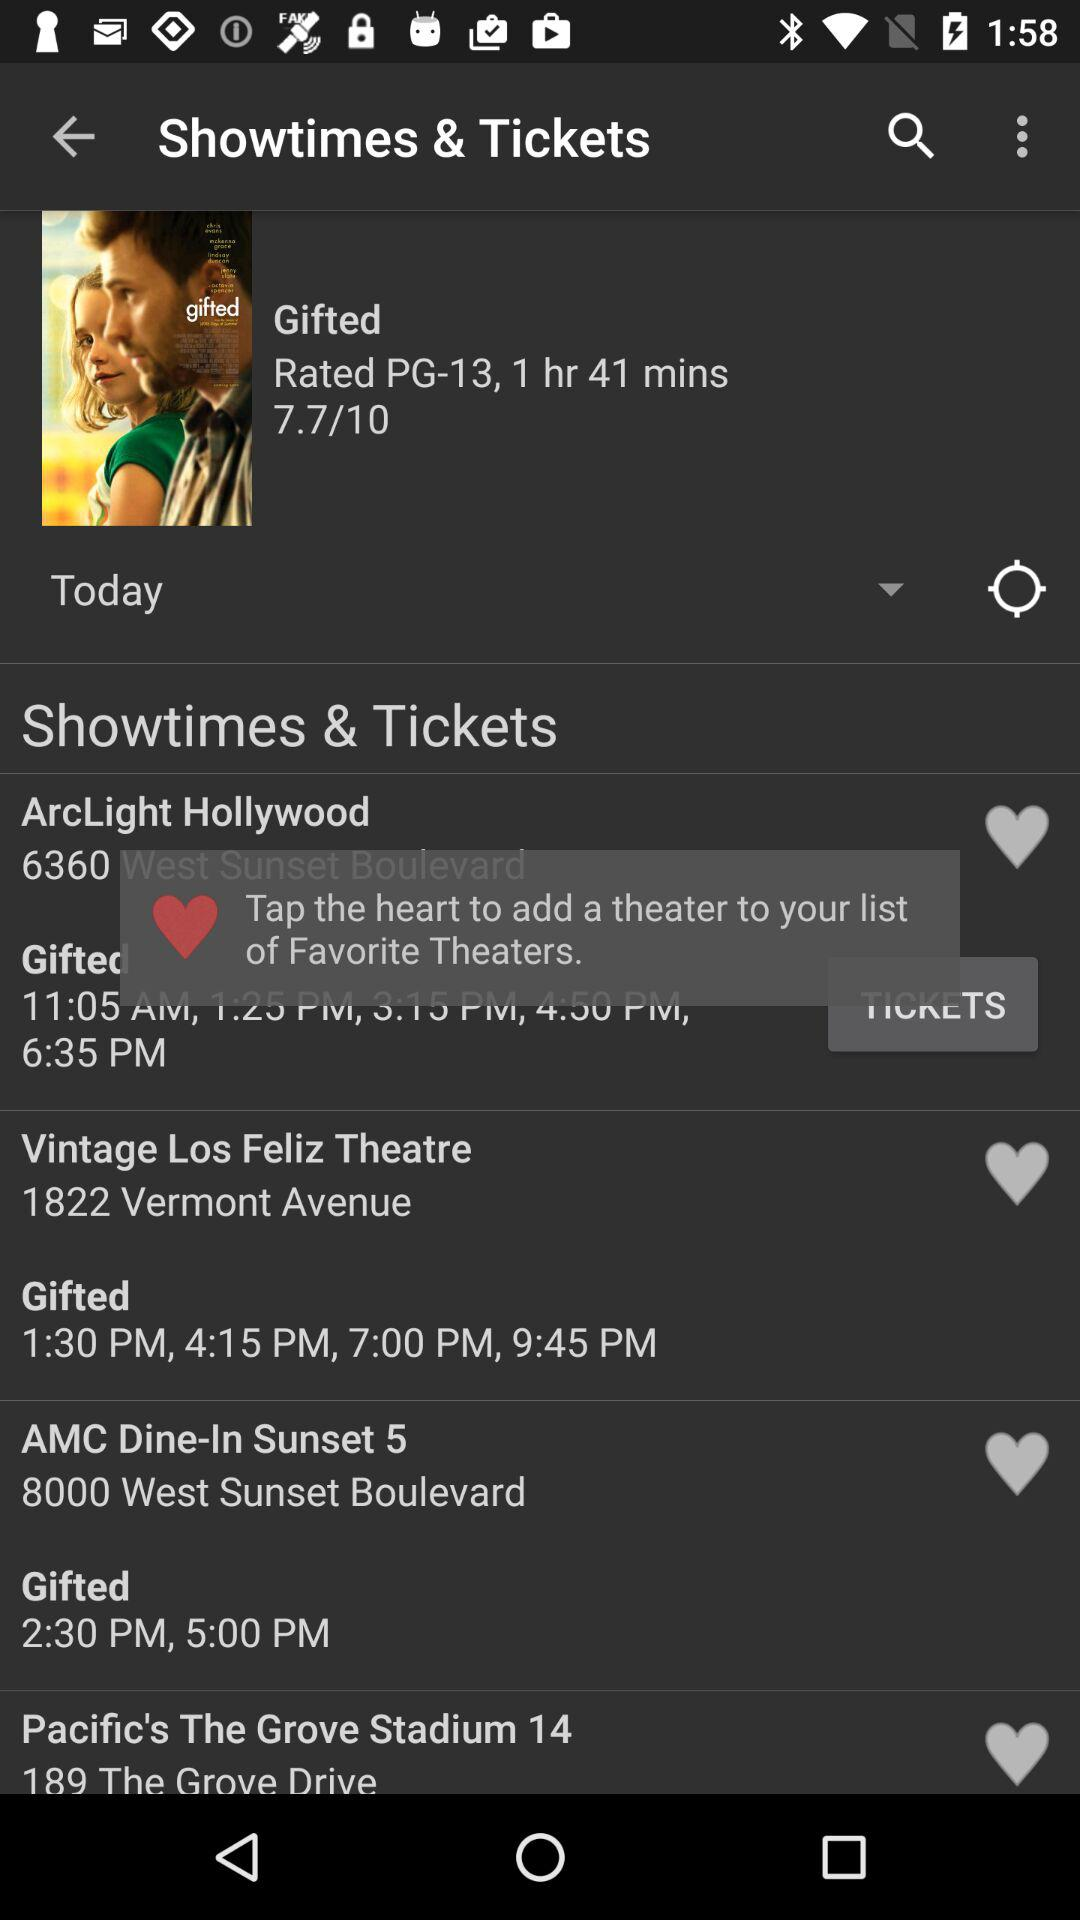What is the movie name? The movie name is "Gifted". 